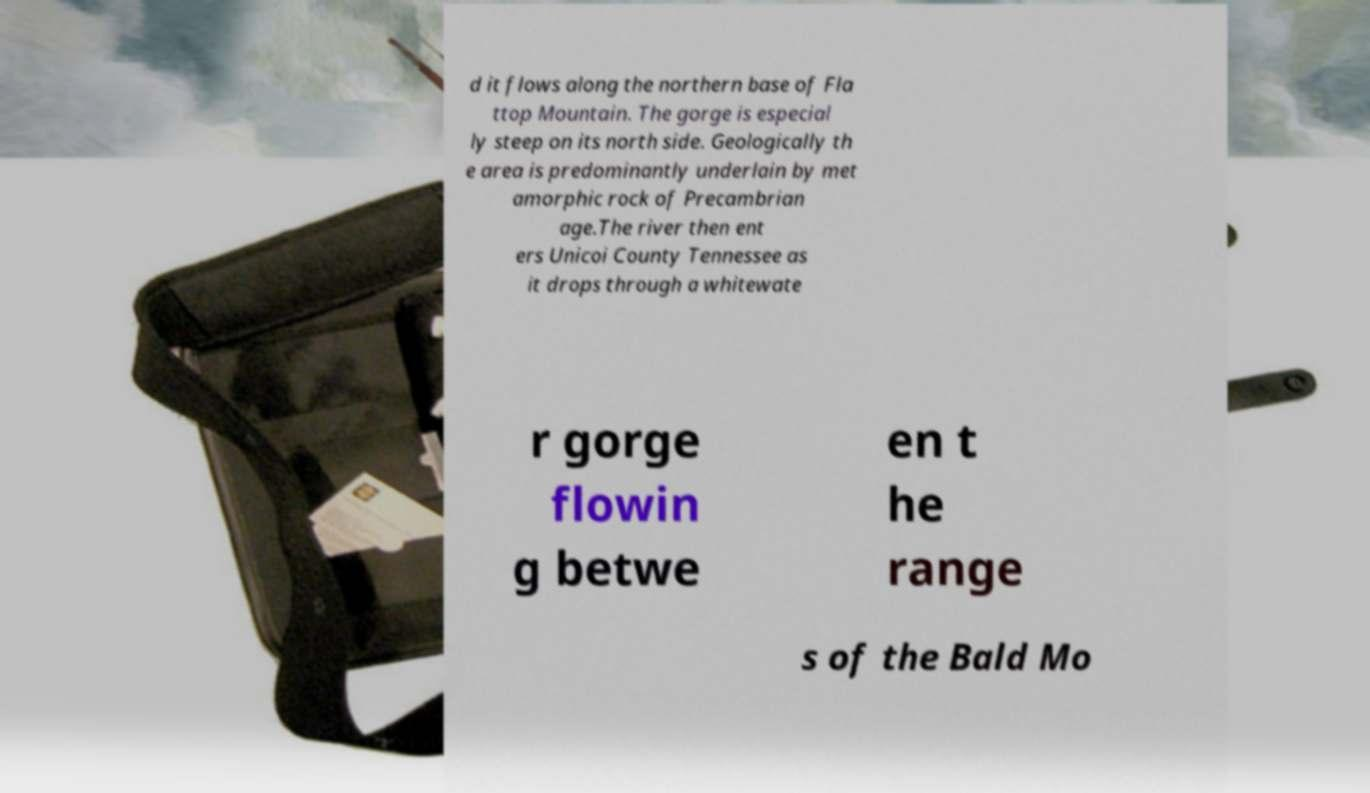For documentation purposes, I need the text within this image transcribed. Could you provide that? d it flows along the northern base of Fla ttop Mountain. The gorge is especial ly steep on its north side. Geologically th e area is predominantly underlain by met amorphic rock of Precambrian age.The river then ent ers Unicoi County Tennessee as it drops through a whitewate r gorge flowin g betwe en t he range s of the Bald Mo 